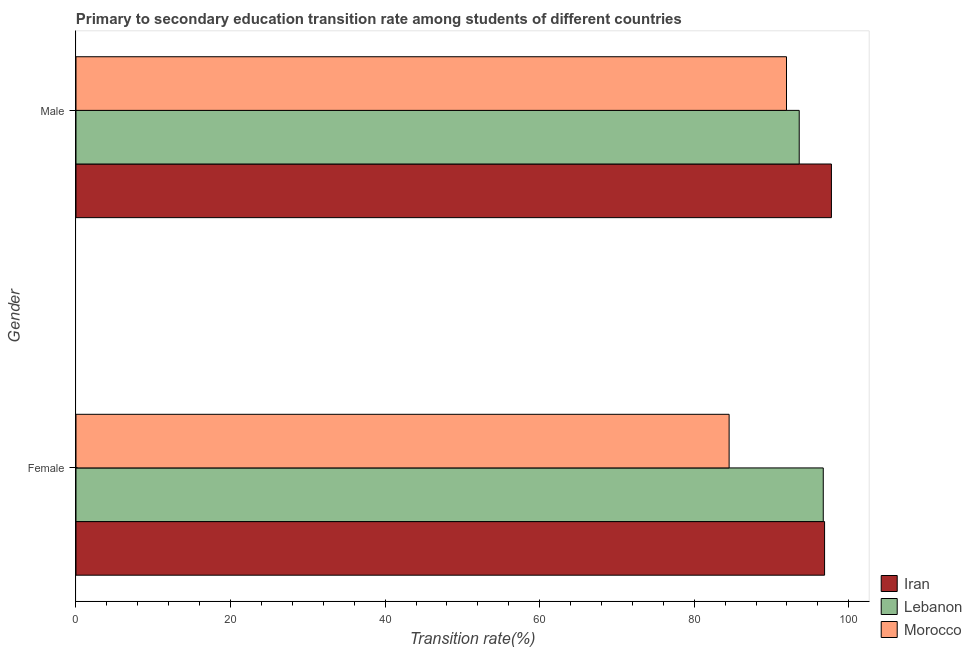How many groups of bars are there?
Offer a terse response. 2. What is the transition rate among male students in Iran?
Give a very brief answer. 97.76. Across all countries, what is the maximum transition rate among female students?
Your answer should be very brief. 96.87. Across all countries, what is the minimum transition rate among male students?
Offer a very short reply. 91.94. In which country was the transition rate among male students maximum?
Ensure brevity in your answer.  Iran. In which country was the transition rate among male students minimum?
Your response must be concise. Morocco. What is the total transition rate among male students in the graph?
Your answer should be compact. 283.29. What is the difference between the transition rate among female students in Morocco and that in Iran?
Offer a very short reply. -12.35. What is the difference between the transition rate among female students in Iran and the transition rate among male students in Morocco?
Provide a short and direct response. 4.93. What is the average transition rate among male students per country?
Your response must be concise. 94.43. What is the difference between the transition rate among male students and transition rate among female students in Morocco?
Make the answer very short. 7.43. What is the ratio of the transition rate among female students in Iran to that in Morocco?
Ensure brevity in your answer.  1.15. In how many countries, is the transition rate among male students greater than the average transition rate among male students taken over all countries?
Provide a short and direct response. 1. What does the 3rd bar from the top in Male represents?
Your answer should be very brief. Iran. What does the 3rd bar from the bottom in Male represents?
Ensure brevity in your answer.  Morocco. How many bars are there?
Keep it short and to the point. 6. Are all the bars in the graph horizontal?
Provide a succinct answer. Yes. How many countries are there in the graph?
Provide a short and direct response. 3. Are the values on the major ticks of X-axis written in scientific E-notation?
Offer a terse response. No. Does the graph contain any zero values?
Give a very brief answer. No. Does the graph contain grids?
Your response must be concise. No. Where does the legend appear in the graph?
Provide a short and direct response. Bottom right. How many legend labels are there?
Ensure brevity in your answer.  3. What is the title of the graph?
Keep it short and to the point. Primary to secondary education transition rate among students of different countries. What is the label or title of the X-axis?
Ensure brevity in your answer.  Transition rate(%). What is the Transition rate(%) in Iran in Female?
Provide a succinct answer. 96.87. What is the Transition rate(%) in Lebanon in Female?
Provide a succinct answer. 96.7. What is the Transition rate(%) of Morocco in Female?
Provide a succinct answer. 84.52. What is the Transition rate(%) in Iran in Male?
Your answer should be very brief. 97.76. What is the Transition rate(%) of Lebanon in Male?
Offer a very short reply. 93.59. What is the Transition rate(%) in Morocco in Male?
Make the answer very short. 91.94. Across all Gender, what is the maximum Transition rate(%) of Iran?
Your answer should be very brief. 97.76. Across all Gender, what is the maximum Transition rate(%) of Lebanon?
Keep it short and to the point. 96.7. Across all Gender, what is the maximum Transition rate(%) in Morocco?
Keep it short and to the point. 91.94. Across all Gender, what is the minimum Transition rate(%) of Iran?
Your answer should be very brief. 96.87. Across all Gender, what is the minimum Transition rate(%) in Lebanon?
Offer a terse response. 93.59. Across all Gender, what is the minimum Transition rate(%) of Morocco?
Provide a succinct answer. 84.52. What is the total Transition rate(%) in Iran in the graph?
Give a very brief answer. 194.63. What is the total Transition rate(%) in Lebanon in the graph?
Keep it short and to the point. 190.29. What is the total Transition rate(%) of Morocco in the graph?
Your response must be concise. 176.46. What is the difference between the Transition rate(%) in Iran in Female and that in Male?
Your answer should be compact. -0.89. What is the difference between the Transition rate(%) in Lebanon in Female and that in Male?
Ensure brevity in your answer.  3.11. What is the difference between the Transition rate(%) of Morocco in Female and that in Male?
Offer a terse response. -7.43. What is the difference between the Transition rate(%) of Iran in Female and the Transition rate(%) of Lebanon in Male?
Provide a succinct answer. 3.28. What is the difference between the Transition rate(%) in Iran in Female and the Transition rate(%) in Morocco in Male?
Provide a short and direct response. 4.93. What is the difference between the Transition rate(%) of Lebanon in Female and the Transition rate(%) of Morocco in Male?
Offer a terse response. 4.76. What is the average Transition rate(%) of Iran per Gender?
Your answer should be compact. 97.31. What is the average Transition rate(%) in Lebanon per Gender?
Your response must be concise. 95.14. What is the average Transition rate(%) of Morocco per Gender?
Ensure brevity in your answer.  88.23. What is the difference between the Transition rate(%) of Iran and Transition rate(%) of Lebanon in Female?
Offer a very short reply. 0.17. What is the difference between the Transition rate(%) in Iran and Transition rate(%) in Morocco in Female?
Your answer should be very brief. 12.35. What is the difference between the Transition rate(%) of Lebanon and Transition rate(%) of Morocco in Female?
Your answer should be very brief. 12.18. What is the difference between the Transition rate(%) of Iran and Transition rate(%) of Lebanon in Male?
Your response must be concise. 4.17. What is the difference between the Transition rate(%) in Iran and Transition rate(%) in Morocco in Male?
Offer a very short reply. 5.81. What is the difference between the Transition rate(%) of Lebanon and Transition rate(%) of Morocco in Male?
Make the answer very short. 1.65. What is the ratio of the Transition rate(%) in Iran in Female to that in Male?
Your answer should be compact. 0.99. What is the ratio of the Transition rate(%) of Lebanon in Female to that in Male?
Provide a short and direct response. 1.03. What is the ratio of the Transition rate(%) of Morocco in Female to that in Male?
Keep it short and to the point. 0.92. What is the difference between the highest and the second highest Transition rate(%) in Iran?
Ensure brevity in your answer.  0.89. What is the difference between the highest and the second highest Transition rate(%) of Lebanon?
Keep it short and to the point. 3.11. What is the difference between the highest and the second highest Transition rate(%) in Morocco?
Make the answer very short. 7.43. What is the difference between the highest and the lowest Transition rate(%) of Iran?
Ensure brevity in your answer.  0.89. What is the difference between the highest and the lowest Transition rate(%) of Lebanon?
Ensure brevity in your answer.  3.11. What is the difference between the highest and the lowest Transition rate(%) of Morocco?
Offer a very short reply. 7.43. 